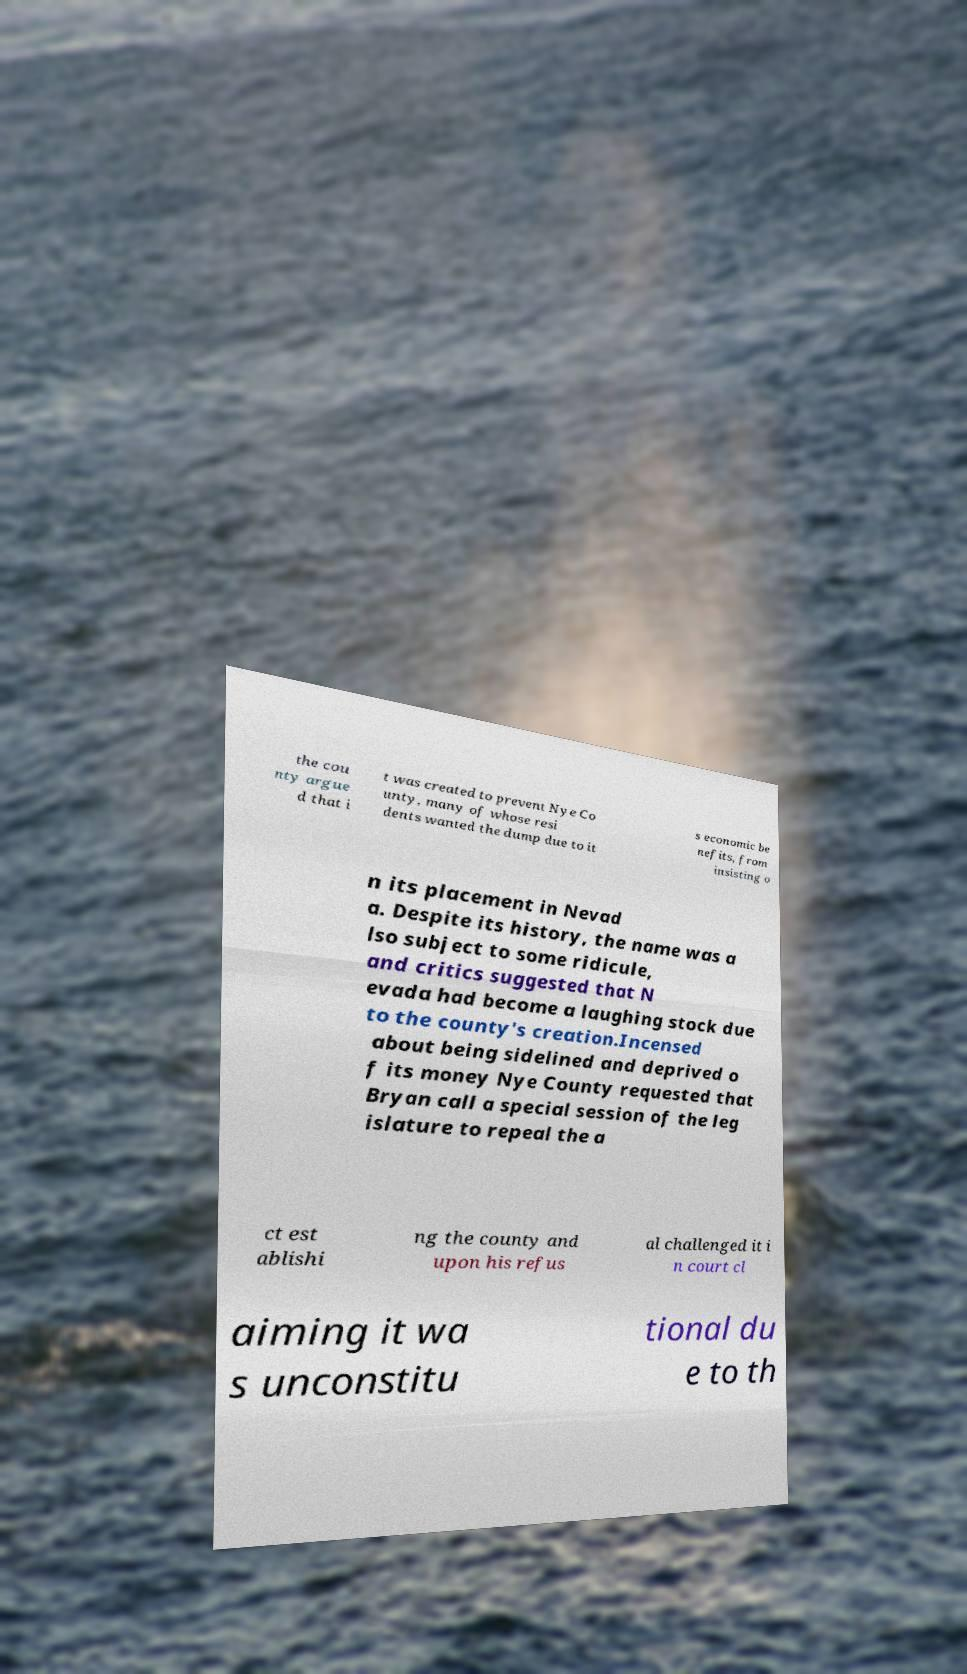Could you assist in decoding the text presented in this image and type it out clearly? the cou nty argue d that i t was created to prevent Nye Co unty, many of whose resi dents wanted the dump due to it s economic be nefits, from insisting o n its placement in Nevad a. Despite its history, the name was a lso subject to some ridicule, and critics suggested that N evada had become a laughing stock due to the county's creation.Incensed about being sidelined and deprived o f its money Nye County requested that Bryan call a special session of the leg islature to repeal the a ct est ablishi ng the county and upon his refus al challenged it i n court cl aiming it wa s unconstitu tional du e to th 